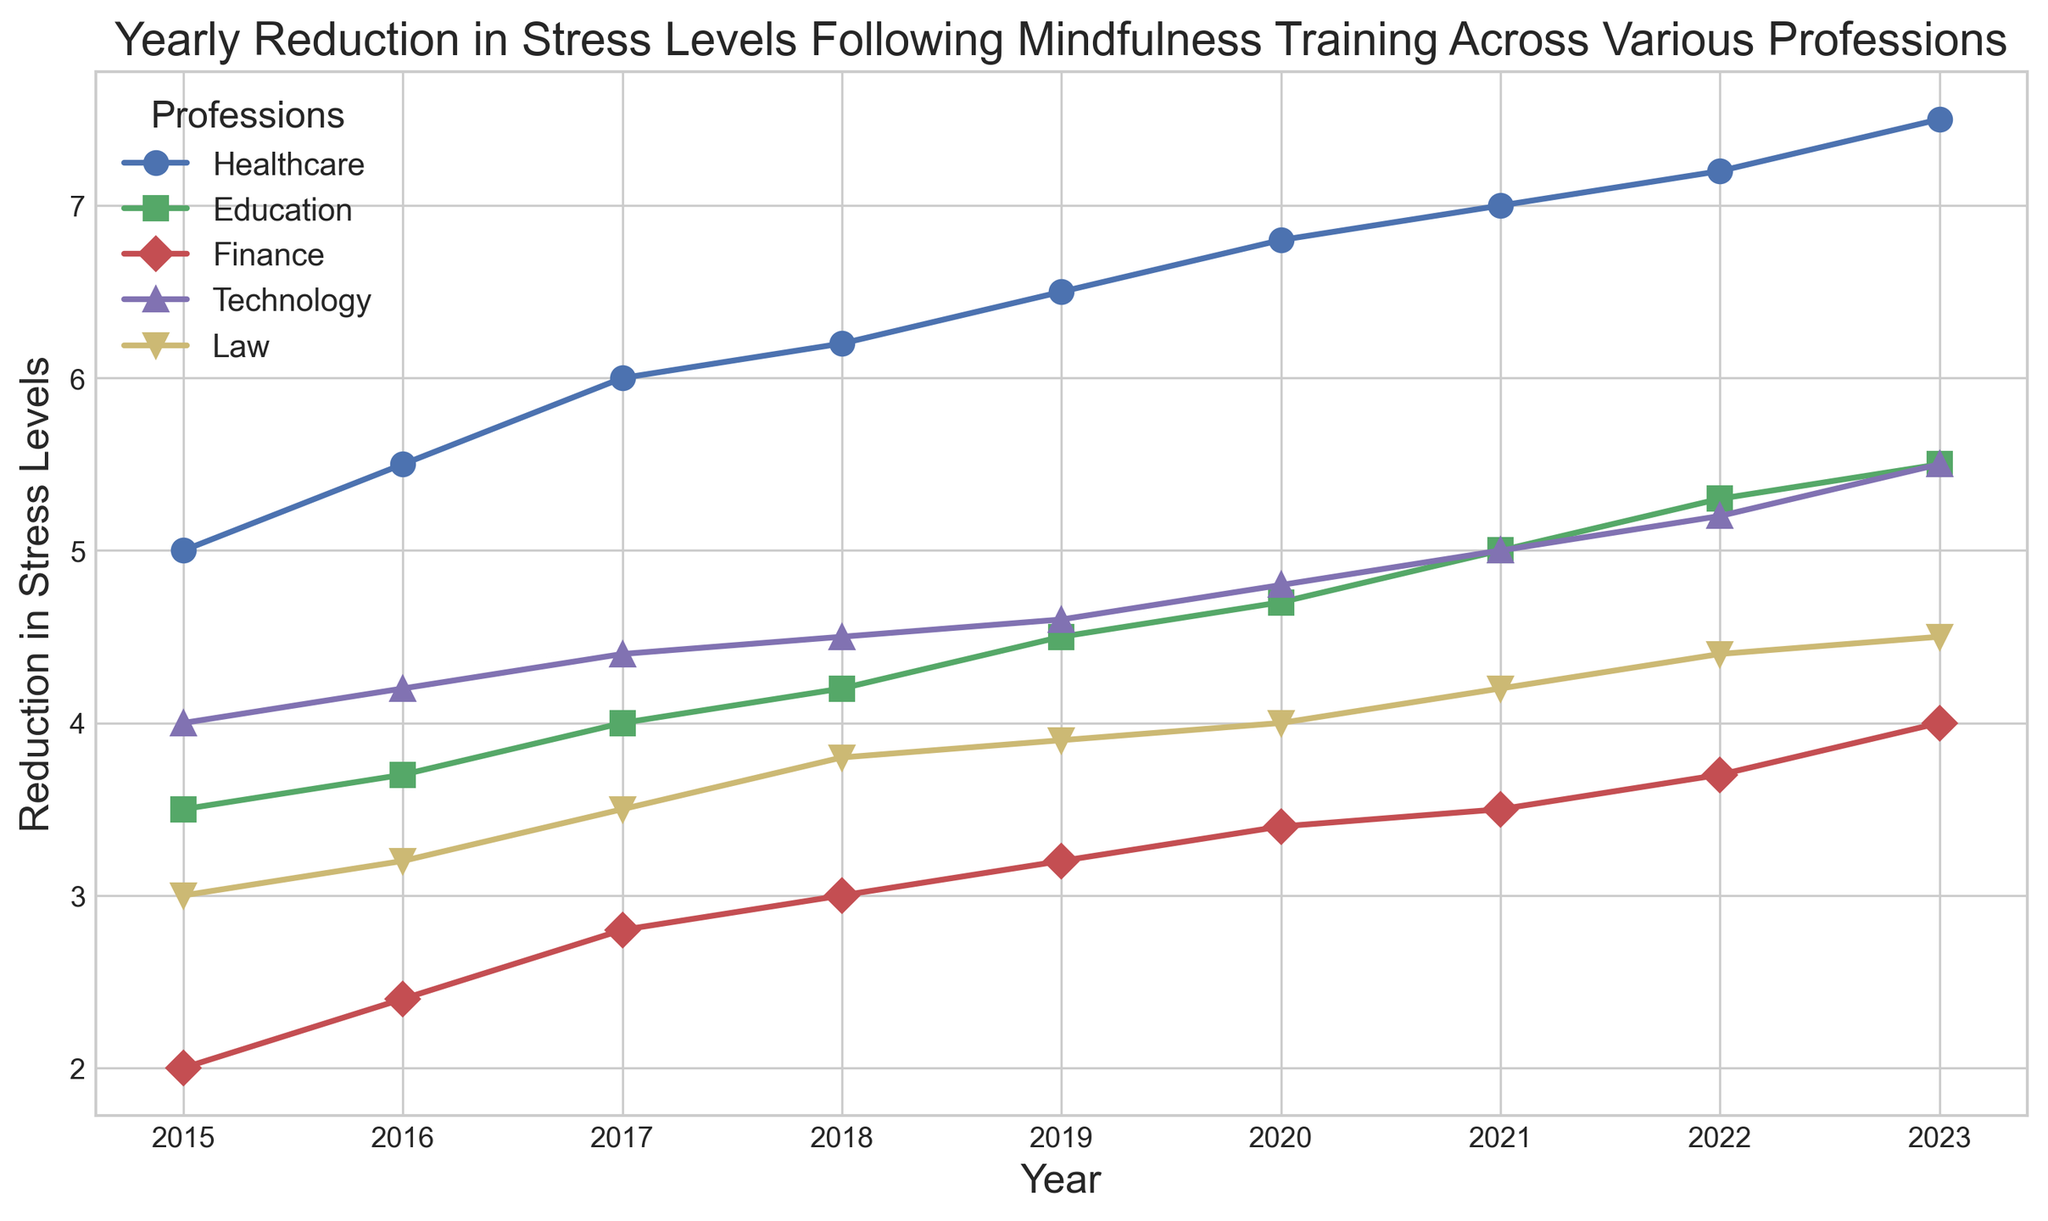Which profession showed the greatest reduction in stress levels by 2023? Examine the data points on the chart for the year 2023 and identify the profession with the highest value. In this case, the lines of the chart show Healthcare having the highest reduction at 7.5 in 2023.
Answer: Healthcare How did the stress levels in the Finance profession change between 2015 and 2023? The stress levels in the Finance profession in 2015 were 2. By 2023, they had increased to 4. Therefore, the change in stress levels can be calculated as 4 - 2 = 2.
Answer: Increased by 2 Between which consecutive years did the Education profession experience the largest increase in stress level reduction? Look at the data points for Education and calculate the differences year-to-year. The largest increase between consecutive years is from 2021 (5) to 2022 (5.3), which is an increase of 0.3.
Answer: 2021 to 2022 Which profession had the least overall reduction in stress levels by 2023? Identify the smallest value among the final values for all professions listed in 2023. Finance has the smallest value at 4.
Answer: Finance Compare the stress level reductions for Education and Technology in 2017. Which profession had a higher reduction? Look at the data points for 2017: Education has a value of 4 and Technology has a value of 4.4. Therefore, Technology had a higher reduction.
Answer: Technology What is the average reduction in stress levels across all professions in 2020? Calculate the average of the values for all professions in 2020: (6.8 + 4.7 + 3.4 + 4.8 + 4)/5 = 4.74.
Answer: 4.74 Which year saw the highest rise in stress level reduction for the Healthcare profession? Examine the data points for Healthcare and find the year-to-year differences, identifying the highest rise. The highest rise is from 2019 (6.5) to 2020 (6.8), which is an increase of 0.3.
Answer: 2019 to 2020 In which year did the Law profession first exceed a stress reduction level of 4? Look at the data points for Law and find the first year where the value exceeds 4. This happens in 2020 with a value of 4.
Answer: 2020 